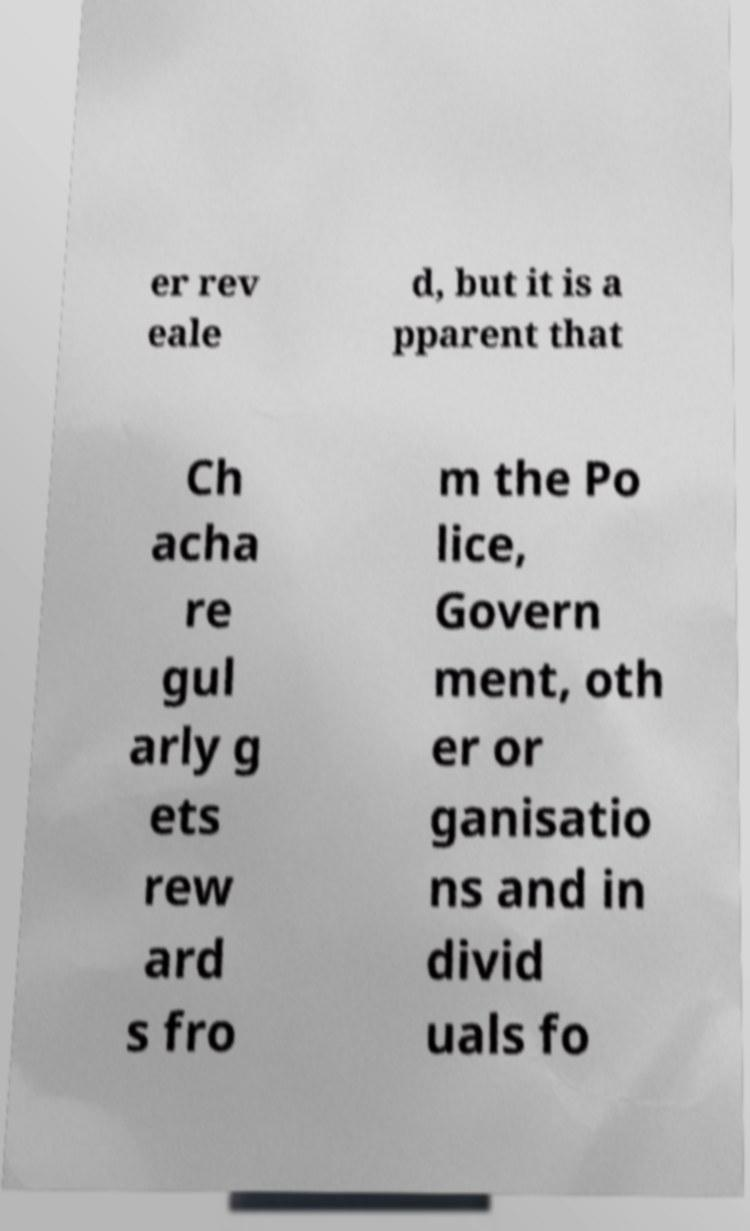Could you assist in decoding the text presented in this image and type it out clearly? er rev eale d, but it is a pparent that Ch acha re gul arly g ets rew ard s fro m the Po lice, Govern ment, oth er or ganisatio ns and in divid uals fo 